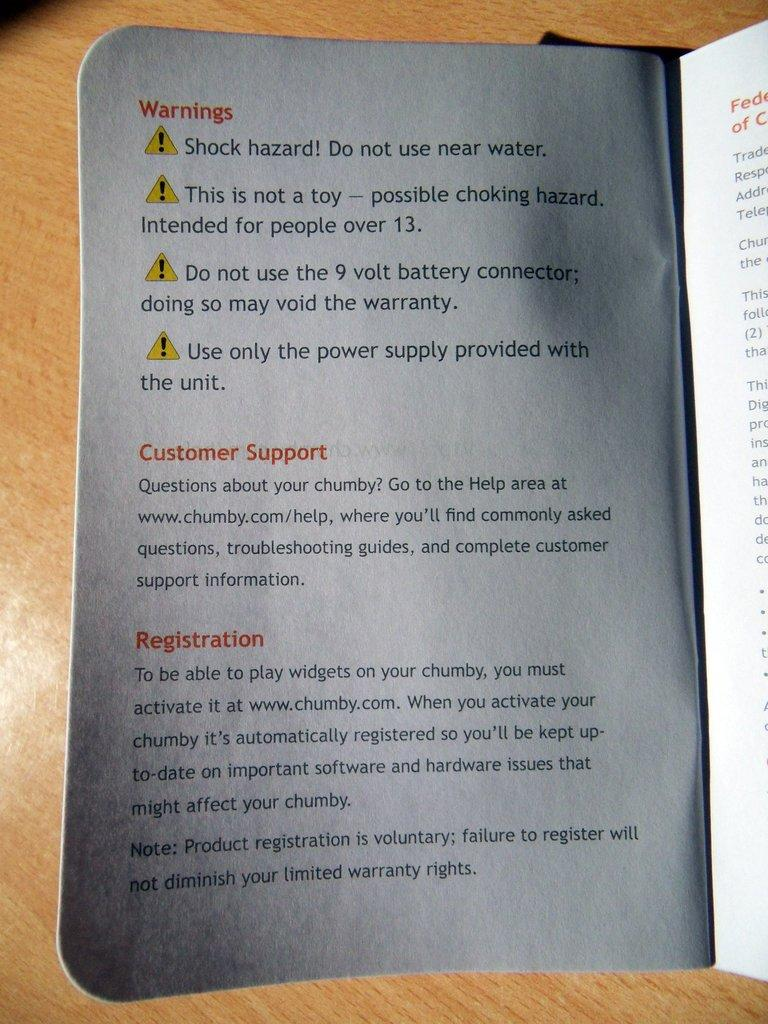<image>
Summarize the visual content of the image. A booklet opened up to the warnings page on an item use with numbers to customer support and for registration facts. 